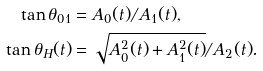<formula> <loc_0><loc_0><loc_500><loc_500>\tan \theta _ { 0 1 } & = { A _ { 0 } ( t ) } / { A _ { 1 } ( t ) } , \\ \tan \theta _ { H } ( t ) & = { \sqrt { A _ { 0 } ^ { 2 } ( t ) + A _ { 1 } ^ { 2 } ( t ) } } / { A _ { 2 } ( t ) } .</formula> 